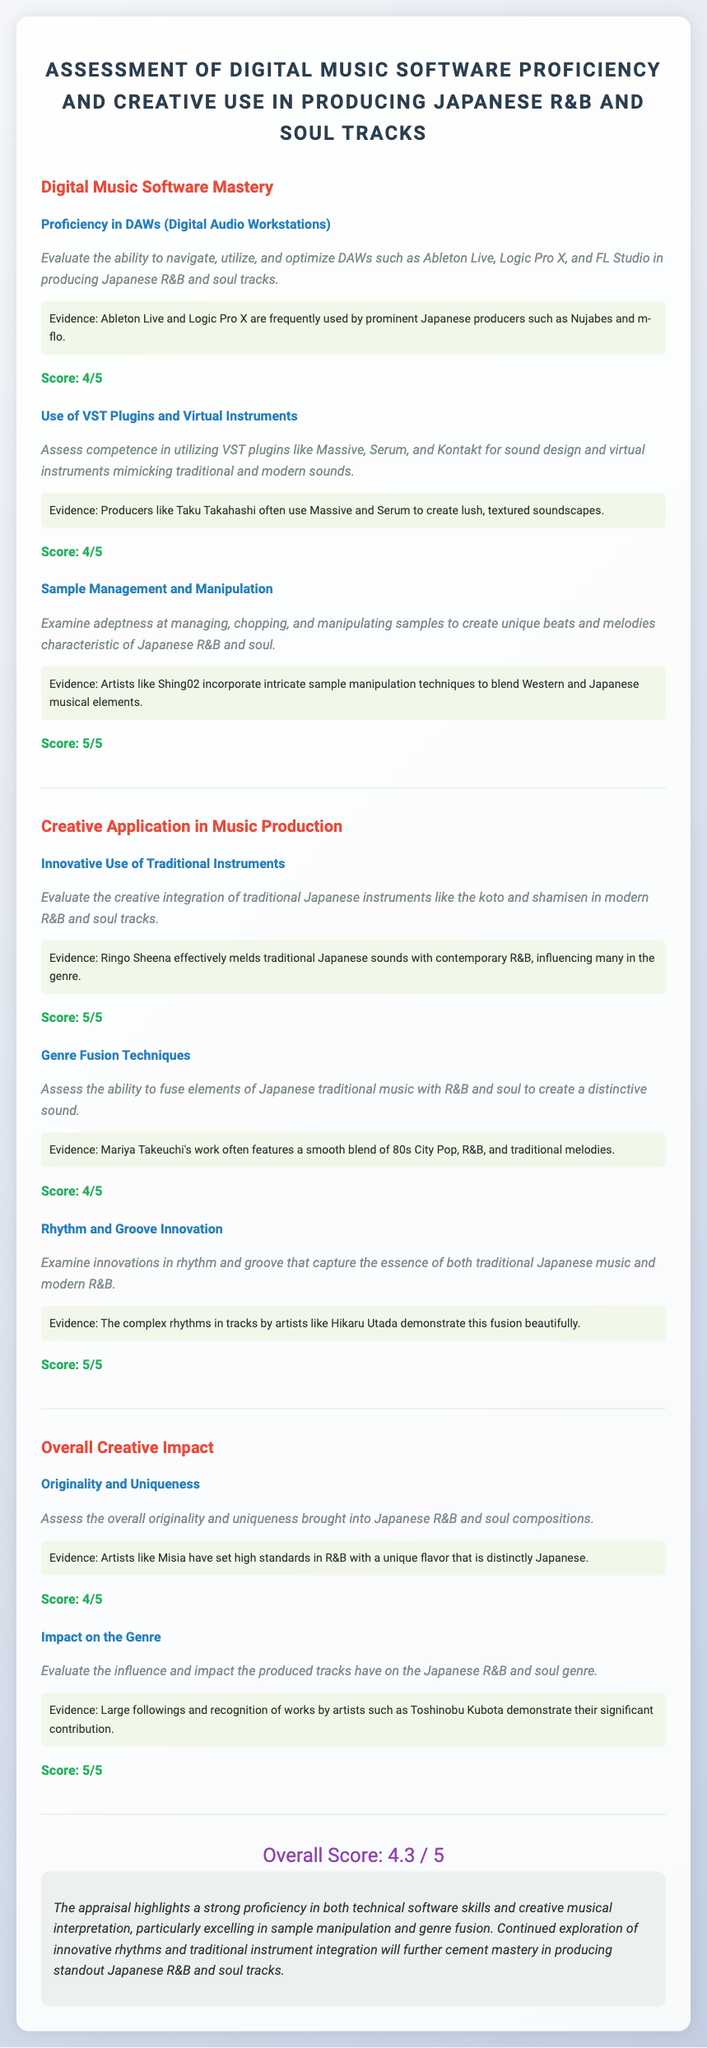What is the title of the assessment? The title of the assessment is presented in the header of the document.
Answer: Assessment of Digital Music Software Proficiency and Creative Use in Producing Japanese R&B and Soul Tracks What is the score for Sample Management and Manipulation? This score is listed under the criterion section for sample management.
Answer: 5/5 Who is mentioned as effectively melding traditional Japanese sounds with contemporary R&B? This information is found in the criterion for Innovative Use of Traditional Instruments.
Answer: Ringo Sheena What score did Genre Fusion Techniques receive? The score is located in the Creative Application section under Genre Fusion Techniques.
Answer: 4/5 How many sections are in the overall creative impact part of the document? The number of sections is derived from the headings in the document.
Answer: 2 What is the overall score of the assessment? The overall score is displayed toward the end of the document.
Answer: 4.3 / 5 What evidence is provided for Rhythm and Groove Innovation? The supporting evidence is listed in the criterion description for this section.
Answer: The complex rhythms in tracks by artists like Hikaru Utada demonstrate this fusion beautifully Which artist's work is mentioned for using Massive and Serum? This artist is referenced in the criterion for VST Plugins and Virtual Instruments.
Answer: Taku Takahashi What major musical elements are highlighted in the creative integration criterion? These elements are specified in the description of the criterion for traditional instruments.
Answer: Traditional Japanese instruments like the koto and shamisen 